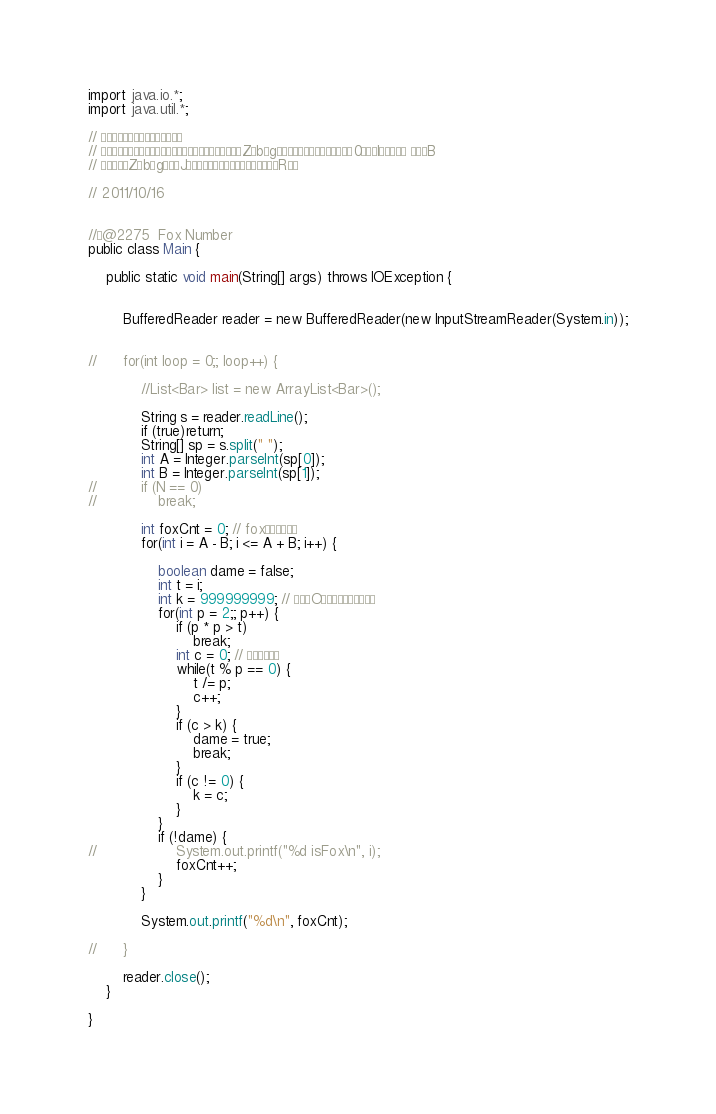<code> <loc_0><loc_0><loc_500><loc_500><_Java_>
import java.io.*;
import java.util.*;

// æ­Ôá¤Æ±ë
// âè¶É¢ÄÈ­ÄàâèZbgÍ¡Åæªª0ÅI¹Å éB
// âèZbgÌJèÔµÉú»Rê

// 2011/10/16


//@2275  Fox Number
public class Main {

	public static void main(String[] args) throws IOException {
		
		
		BufferedReader reader = new BufferedReader(new InputStreamReader(System.in));

		
//		for(int loop = 0;; loop++) {

			//List<Bar> list = new ArrayList<Bar>();

			String s = reader.readLine();
			if (true)return;
			String[] sp = s.split(" ");
			int A = Integer.parseInt(sp[0]);
			int B = Integer.parseInt(sp[1]);
//			if (N == 0)
//				break;
			
			int foxCnt = 0; // foxÌ
			for(int i = A - B; i <= A + B; i++) {
				
				boolean dame = false;
				int t = i;
				int k = 999999999; // ¼OÌ×«·¤
				for(int p = 2;; p++) {
					if (p * p > t)
						break;
					int c = 0; // ×«
					while(t % p == 0) {
						t /= p;
						c++;
					}
					if (c > k) {
						dame = true;
						break;
					}
					if (c != 0) {
						k = c;
					}
				}
				if (!dame) {
//					System.out.printf("%d isFox\n", i);
					foxCnt++;
				}
			}

			System.out.printf("%d\n", foxCnt);
				
//		}		
		
		reader.close();
	}

}</code> 